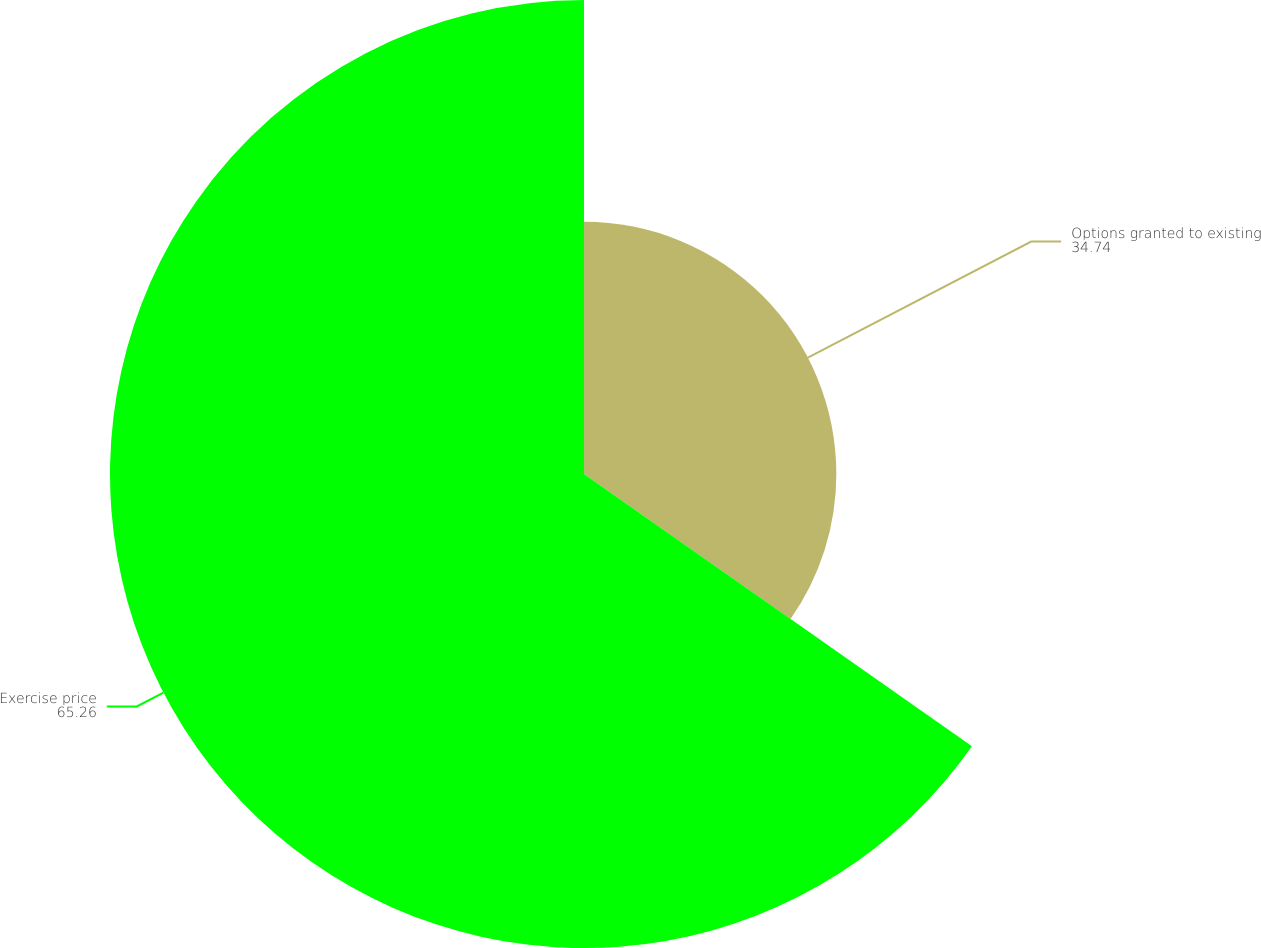Convert chart to OTSL. <chart><loc_0><loc_0><loc_500><loc_500><pie_chart><fcel>Options granted to existing<fcel>Exercise price<nl><fcel>34.74%<fcel>65.26%<nl></chart> 